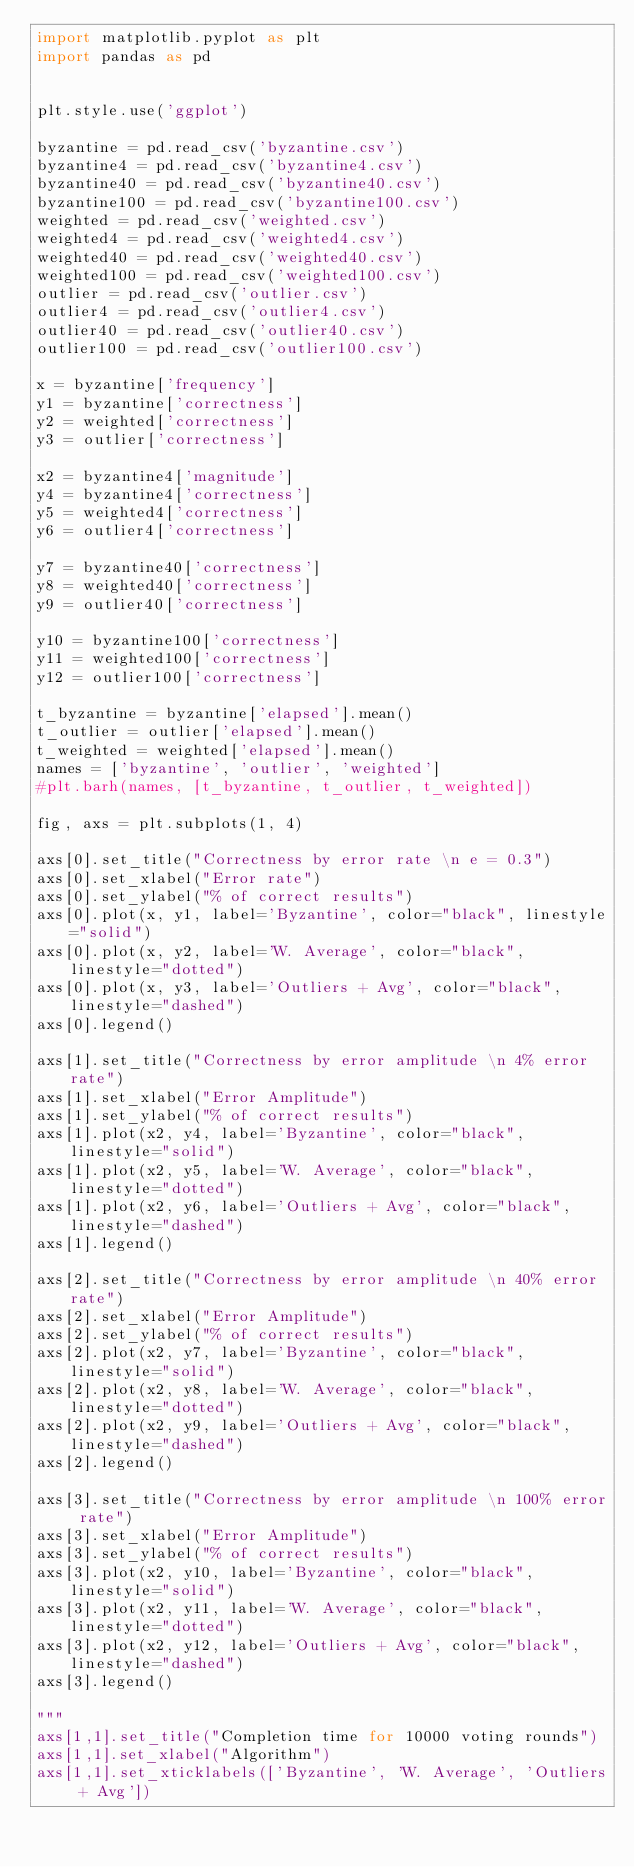<code> <loc_0><loc_0><loc_500><loc_500><_Python_>import matplotlib.pyplot as plt
import pandas as pd


plt.style.use('ggplot')

byzantine = pd.read_csv('byzantine.csv')
byzantine4 = pd.read_csv('byzantine4.csv')
byzantine40 = pd.read_csv('byzantine40.csv')
byzantine100 = pd.read_csv('byzantine100.csv')
weighted = pd.read_csv('weighted.csv')
weighted4 = pd.read_csv('weighted4.csv')
weighted40 = pd.read_csv('weighted40.csv')
weighted100 = pd.read_csv('weighted100.csv')
outlier = pd.read_csv('outlier.csv')
outlier4 = pd.read_csv('outlier4.csv')
outlier40 = pd.read_csv('outlier40.csv')
outlier100 = pd.read_csv('outlier100.csv')

x = byzantine['frequency']
y1 = byzantine['correctness']
y2 = weighted['correctness']
y3 = outlier['correctness']

x2 = byzantine4['magnitude']
y4 = byzantine4['correctness']
y5 = weighted4['correctness']
y6 = outlier4['correctness']

y7 = byzantine40['correctness']
y8 = weighted40['correctness']
y9 = outlier40['correctness']

y10 = byzantine100['correctness']
y11 = weighted100['correctness']
y12 = outlier100['correctness']

t_byzantine = byzantine['elapsed'].mean()
t_outlier = outlier['elapsed'].mean()
t_weighted = weighted['elapsed'].mean()
names = ['byzantine', 'outlier', 'weighted']
#plt.barh(names, [t_byzantine, t_outlier, t_weighted])

fig, axs = plt.subplots(1, 4)

axs[0].set_title("Correctness by error rate \n e = 0.3")
axs[0].set_xlabel("Error rate")
axs[0].set_ylabel("% of correct results")
axs[0].plot(x, y1, label='Byzantine', color="black", linestyle="solid")
axs[0].plot(x, y2, label='W. Average', color="black", linestyle="dotted")
axs[0].plot(x, y3, label='Outliers + Avg', color="black", linestyle="dashed")
axs[0].legend()

axs[1].set_title("Correctness by error amplitude \n 4% error rate")
axs[1].set_xlabel("Error Amplitude")
axs[1].set_ylabel("% of correct results")
axs[1].plot(x2, y4, label='Byzantine', color="black", linestyle="solid")
axs[1].plot(x2, y5, label='W. Average', color="black", linestyle="dotted")
axs[1].plot(x2, y6, label='Outliers + Avg', color="black", linestyle="dashed")
axs[1].legend()

axs[2].set_title("Correctness by error amplitude \n 40% error rate")
axs[2].set_xlabel("Error Amplitude")
axs[2].set_ylabel("% of correct results")
axs[2].plot(x2, y7, label='Byzantine', color="black", linestyle="solid")
axs[2].plot(x2, y8, label='W. Average', color="black", linestyle="dotted")
axs[2].plot(x2, y9, label='Outliers + Avg', color="black", linestyle="dashed")
axs[2].legend()

axs[3].set_title("Correctness by error amplitude \n 100% error rate")
axs[3].set_xlabel("Error Amplitude")
axs[3].set_ylabel("% of correct results")
axs[3].plot(x2, y10, label='Byzantine', color="black", linestyle="solid")
axs[3].plot(x2, y11, label='W. Average', color="black", linestyle="dotted")
axs[3].plot(x2, y12, label='Outliers + Avg', color="black", linestyle="dashed")
axs[3].legend()

"""
axs[1,1].set_title("Completion time for 10000 voting rounds")
axs[1,1].set_xlabel("Algorithm")
axs[1,1].set_xticklabels(['Byzantine', 'W. Average', 'Outliers + Avg'])</code> 